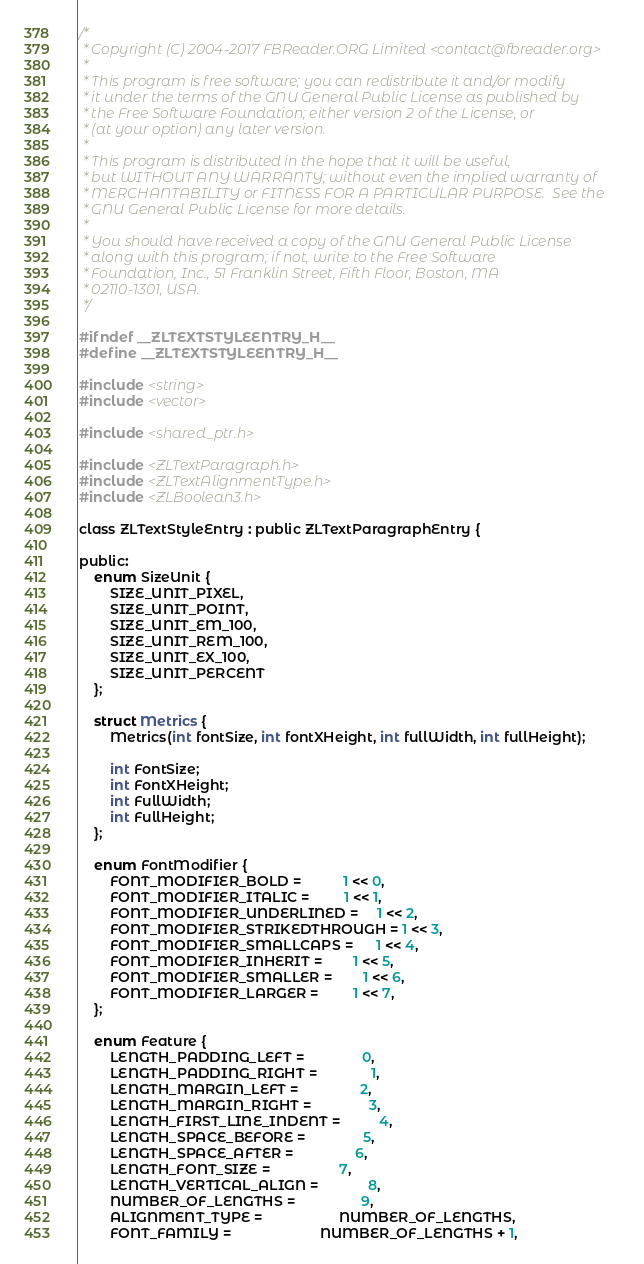<code> <loc_0><loc_0><loc_500><loc_500><_C_>/*
 * Copyright (C) 2004-2017 FBReader.ORG Limited <contact@fbreader.org>
 *
 * This program is free software; you can redistribute it and/or modify
 * it under the terms of the GNU General Public License as published by
 * the Free Software Foundation; either version 2 of the License, or
 * (at your option) any later version.
 *
 * This program is distributed in the hope that it will be useful,
 * but WITHOUT ANY WARRANTY; without even the implied warranty of
 * MERCHANTABILITY or FITNESS FOR A PARTICULAR PURPOSE.  See the
 * GNU General Public License for more details.
 *
 * You should have received a copy of the GNU General Public License
 * along with this program; if not, write to the Free Software
 * Foundation, Inc., 51 Franklin Street, Fifth Floor, Boston, MA
 * 02110-1301, USA.
 */

#ifndef __ZLTEXTSTYLEENTRY_H__
#define __ZLTEXTSTYLEENTRY_H__

#include <string>
#include <vector>

#include <shared_ptr.h>

#include <ZLTextParagraph.h>
#include <ZLTextAlignmentType.h>
#include <ZLBoolean3.h>

class ZLTextStyleEntry : public ZLTextParagraphEntry {

public:
	enum SizeUnit {
		SIZE_UNIT_PIXEL,
		SIZE_UNIT_POINT,
		SIZE_UNIT_EM_100,
		SIZE_UNIT_REM_100,
		SIZE_UNIT_EX_100,
		SIZE_UNIT_PERCENT
	};

	struct Metrics {
		Metrics(int fontSize, int fontXHeight, int fullWidth, int fullHeight);

		int FontSize;
		int FontXHeight;
		int FullWidth;
		int FullHeight;
	};

	enum FontModifier {
		FONT_MODIFIER_BOLD =           1 << 0,
		FONT_MODIFIER_ITALIC =         1 << 1,
		FONT_MODIFIER_UNDERLINED =     1 << 2,
		FONT_MODIFIER_STRIKEDTHROUGH = 1 << 3,
		FONT_MODIFIER_SMALLCAPS =      1 << 4,
		FONT_MODIFIER_INHERIT =        1 << 5,
		FONT_MODIFIER_SMALLER =        1 << 6,
		FONT_MODIFIER_LARGER =         1 << 7,
	};

	enum Feature {
		LENGTH_PADDING_LEFT =               0,
		LENGTH_PADDING_RIGHT =              1,
		LENGTH_MARGIN_LEFT =                2,
		LENGTH_MARGIN_RIGHT =               3,
		LENGTH_FIRST_LINE_INDENT =          4,
		LENGTH_SPACE_BEFORE =               5,
		LENGTH_SPACE_AFTER =                6,
		LENGTH_FONT_SIZE =                  7,
		LENGTH_VERTICAL_ALIGN =             8,
		NUMBER_OF_LENGTHS =                 9,
		ALIGNMENT_TYPE =                    NUMBER_OF_LENGTHS,
		FONT_FAMILY =                       NUMBER_OF_LENGTHS + 1,</code> 